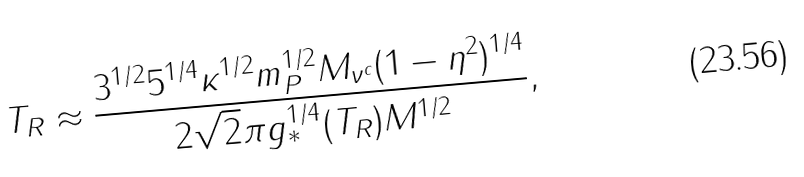<formula> <loc_0><loc_0><loc_500><loc_500>T _ { R } \approx \frac { 3 ^ { 1 / 2 } 5 ^ { 1 / 4 } \kappa ^ { 1 / 2 } m _ { P } ^ { 1 / 2 } M _ { \nu ^ { c } } ( 1 - \eta ^ { 2 } ) ^ { 1 / 4 } } { 2 \sqrt { 2 } \pi g _ { * } ^ { 1 / 4 } ( T _ { R } ) M ^ { 1 / 2 } } ,</formula> 